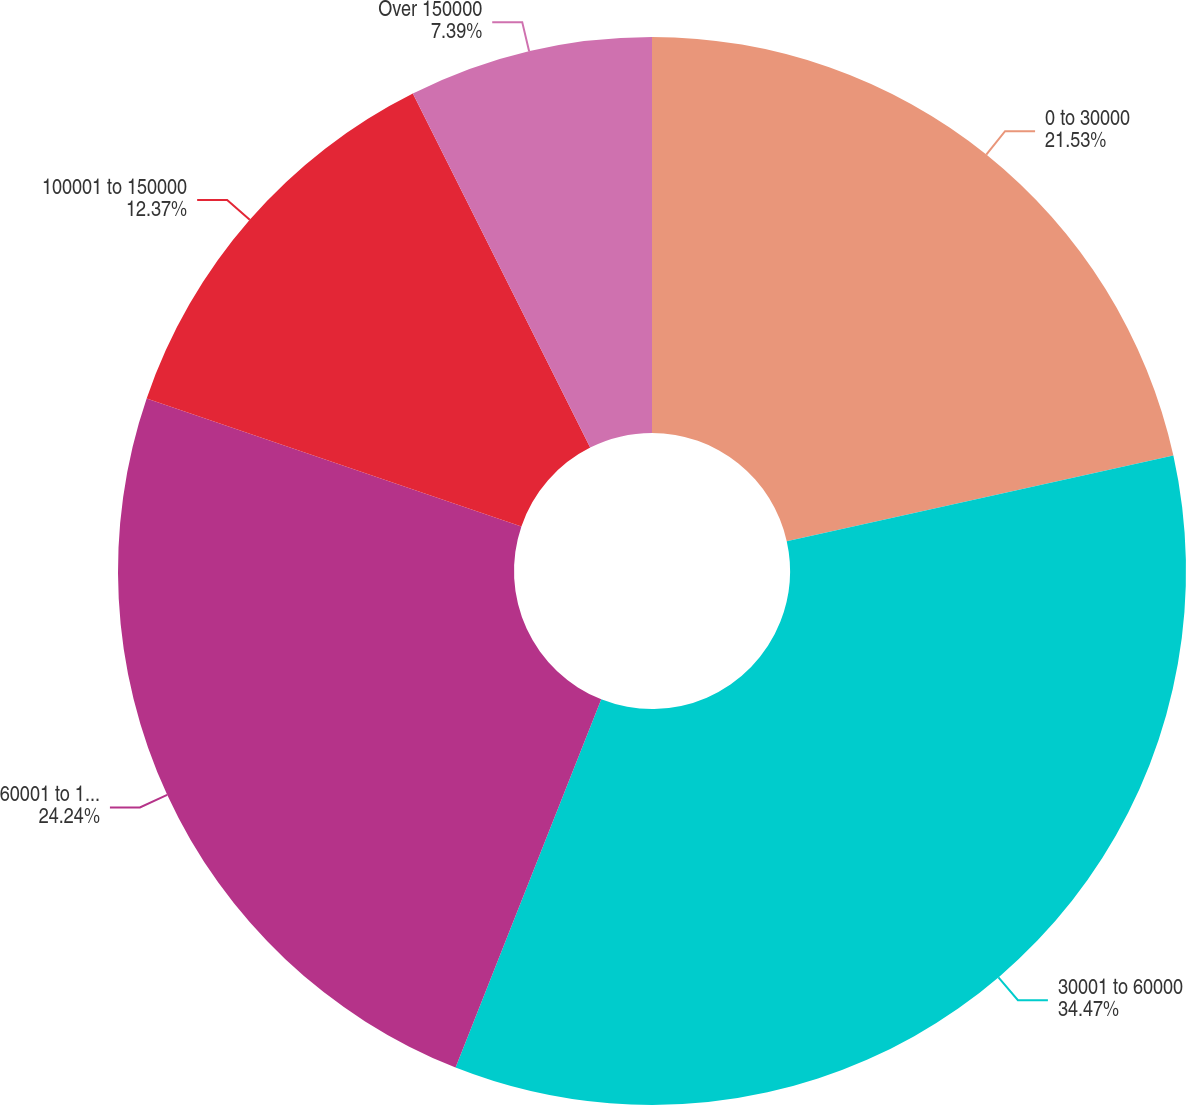Convert chart to OTSL. <chart><loc_0><loc_0><loc_500><loc_500><pie_chart><fcel>0 to 30000<fcel>30001 to 60000<fcel>60001 to 100000<fcel>100001 to 150000<fcel>Over 150000<nl><fcel>21.53%<fcel>34.46%<fcel>24.24%<fcel>12.37%<fcel>7.39%<nl></chart> 